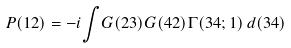<formula> <loc_0><loc_0><loc_500><loc_500>P ( 1 2 ) = - i { \int } G ( 2 3 ) G ( 4 2 ) { \Gamma } ( 3 4 ; 1 ) \, d ( 3 4 )</formula> 